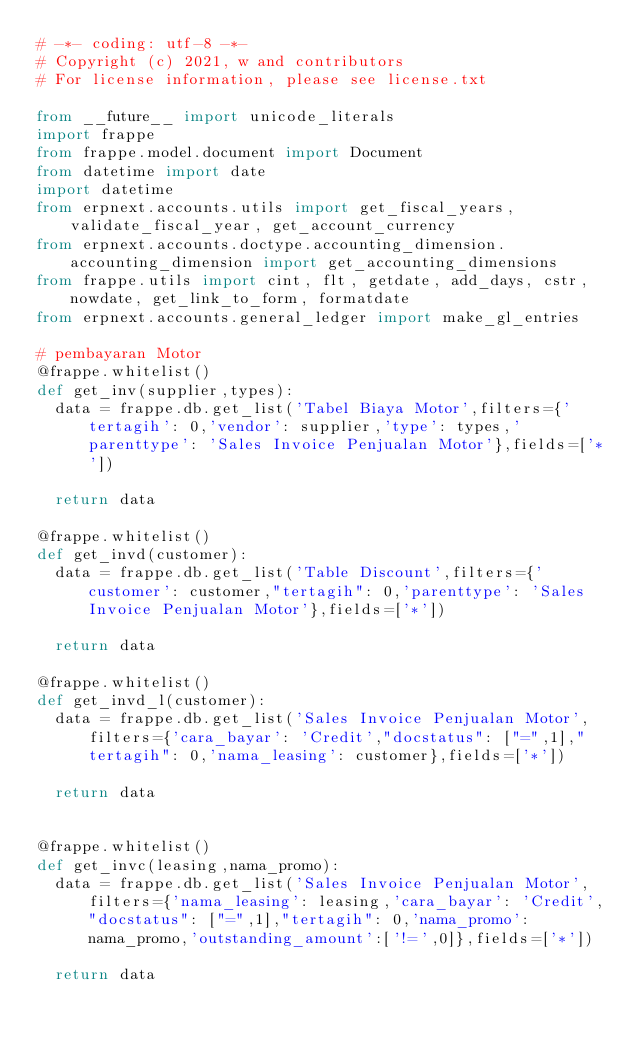Convert code to text. <code><loc_0><loc_0><loc_500><loc_500><_Python_># -*- coding: utf-8 -*-
# Copyright (c) 2021, w and contributors
# For license information, please see license.txt

from __future__ import unicode_literals
import frappe
from frappe.model.document import Document
from datetime import date
import datetime
from erpnext.accounts.utils import get_fiscal_years, validate_fiscal_year, get_account_currency
from erpnext.accounts.doctype.accounting_dimension.accounting_dimension import get_accounting_dimensions
from frappe.utils import cint, flt, getdate, add_days, cstr, nowdate, get_link_to_form, formatdate
from erpnext.accounts.general_ledger import make_gl_entries

# pembayaran Motor
@frappe.whitelist()
def get_inv(supplier,types):
	data = frappe.db.get_list('Tabel Biaya Motor',filters={'tertagih': 0,'vendor': supplier,'type': types,'parenttype': 'Sales Invoice Penjualan Motor'},fields=['*'])

	return data

@frappe.whitelist()
def get_invd(customer):
	data = frappe.db.get_list('Table Discount',filters={'customer': customer,"tertagih": 0,'parenttype': 'Sales Invoice Penjualan Motor'},fields=['*'])

	return data

@frappe.whitelist()
def get_invd_l(customer):
	data = frappe.db.get_list('Sales Invoice Penjualan Motor',filters={'cara_bayar': 'Credit',"docstatus": ["=",1],"tertagih": 0,'nama_leasing': customer},fields=['*'])

	return data


@frappe.whitelist()
def get_invc(leasing,nama_promo):
	data = frappe.db.get_list('Sales Invoice Penjualan Motor',filters={'nama_leasing': leasing,'cara_bayar': 'Credit',"docstatus": ["=",1],"tertagih": 0,'nama_promo': nama_promo,'outstanding_amount':['!=',0]},fields=['*'])

	return data</code> 